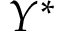<formula> <loc_0><loc_0><loc_500><loc_500>Y ^ { \ast }</formula> 